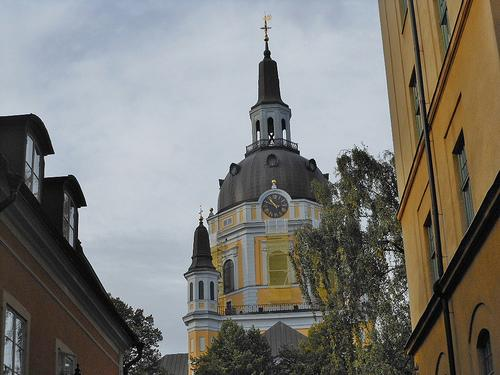Summarize the key elements in the image with a focus on architecture. Church featuring gray dome-shaped roofs, a cross at the tower's tip, windows in different shapes and sizes, and a big yellow and black clock on the wall. Highlight the key architectural features of the church in the image. The church showcases a gray dome-shaped roof, a bell tower with a cross on top, and a variety of differently shaped windows. Provide a brief description of the color scheme in the image. The image has shades of gray for domes and sky, yellow for the clock and parts of the wall, and brown for another portion of the wall. Describe the religious symbol found in the image. There is a cross prominently positioned at the top of the tower, symbolizing the religious significance of the building. Identify a small architectural detail found in the image. A circular window is a notable detail in the building, adding to its overall architectural interest. Describe the weather and environment around the building in the image. A thick white cloud formation is covering the sky, with the sky itself appearing grey in color above the church building. Describe the antennae featured in the image. There is an antennae visible in the image, located close to the cross at the top of the tower and appearing quite slender with a sharp top. Provide a description of the foliage depicted in the image. The image showcases some leaves in the foreground, with a larger group of leaves occupying the midsection of the image. Mention the most prominent feature of the building. A striking gray dome-shaped roof is the focal point of the church building in the image. Narrate the overall appearance of the clock depicted in the image. The clock is characterized by big yellow and black design with a distinctive presence on the top of the church wall. 